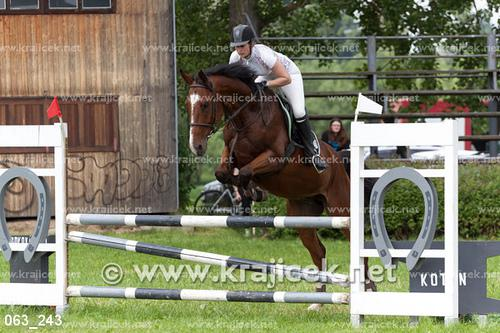Question: who is in the background?
Choices:
A. A woman.
B. A clown.
C. A chef.
D. A politician.
Answer with the letter. Answer: A Question: what is the animal?
Choices:
A. A zebra.
B. A horse.
C. A wolf.
D. A rhino.
Answer with the letter. Answer: B Question: what is the horse doing?
Choices:
A. Dancing.
B. Jumping.
C. Running.
D. Walking.
Answer with the letter. Answer: B Question: who is on the horse?
Choices:
A. A person.
B. A policeman.
C. A fireman.
D. A clown.
Answer with the letter. Answer: A 